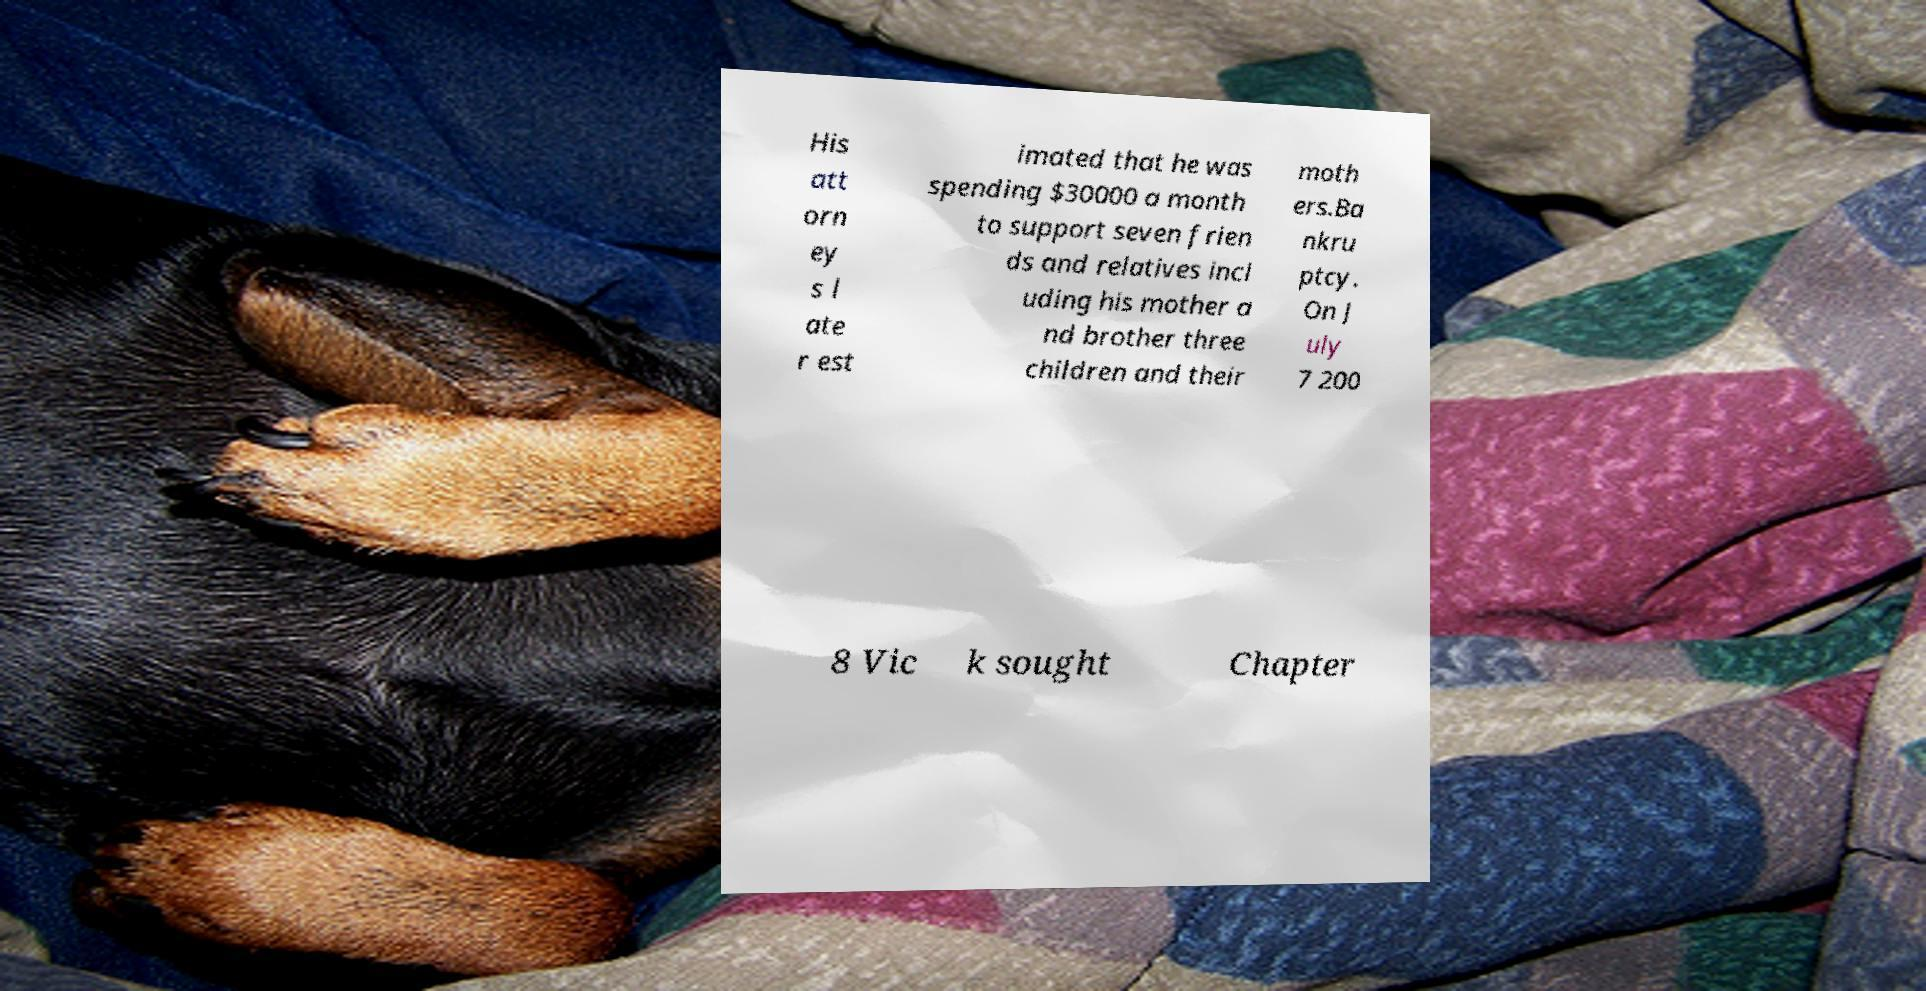There's text embedded in this image that I need extracted. Can you transcribe it verbatim? His att orn ey s l ate r est imated that he was spending $30000 a month to support seven frien ds and relatives incl uding his mother a nd brother three children and their moth ers.Ba nkru ptcy. On J uly 7 200 8 Vic k sought Chapter 